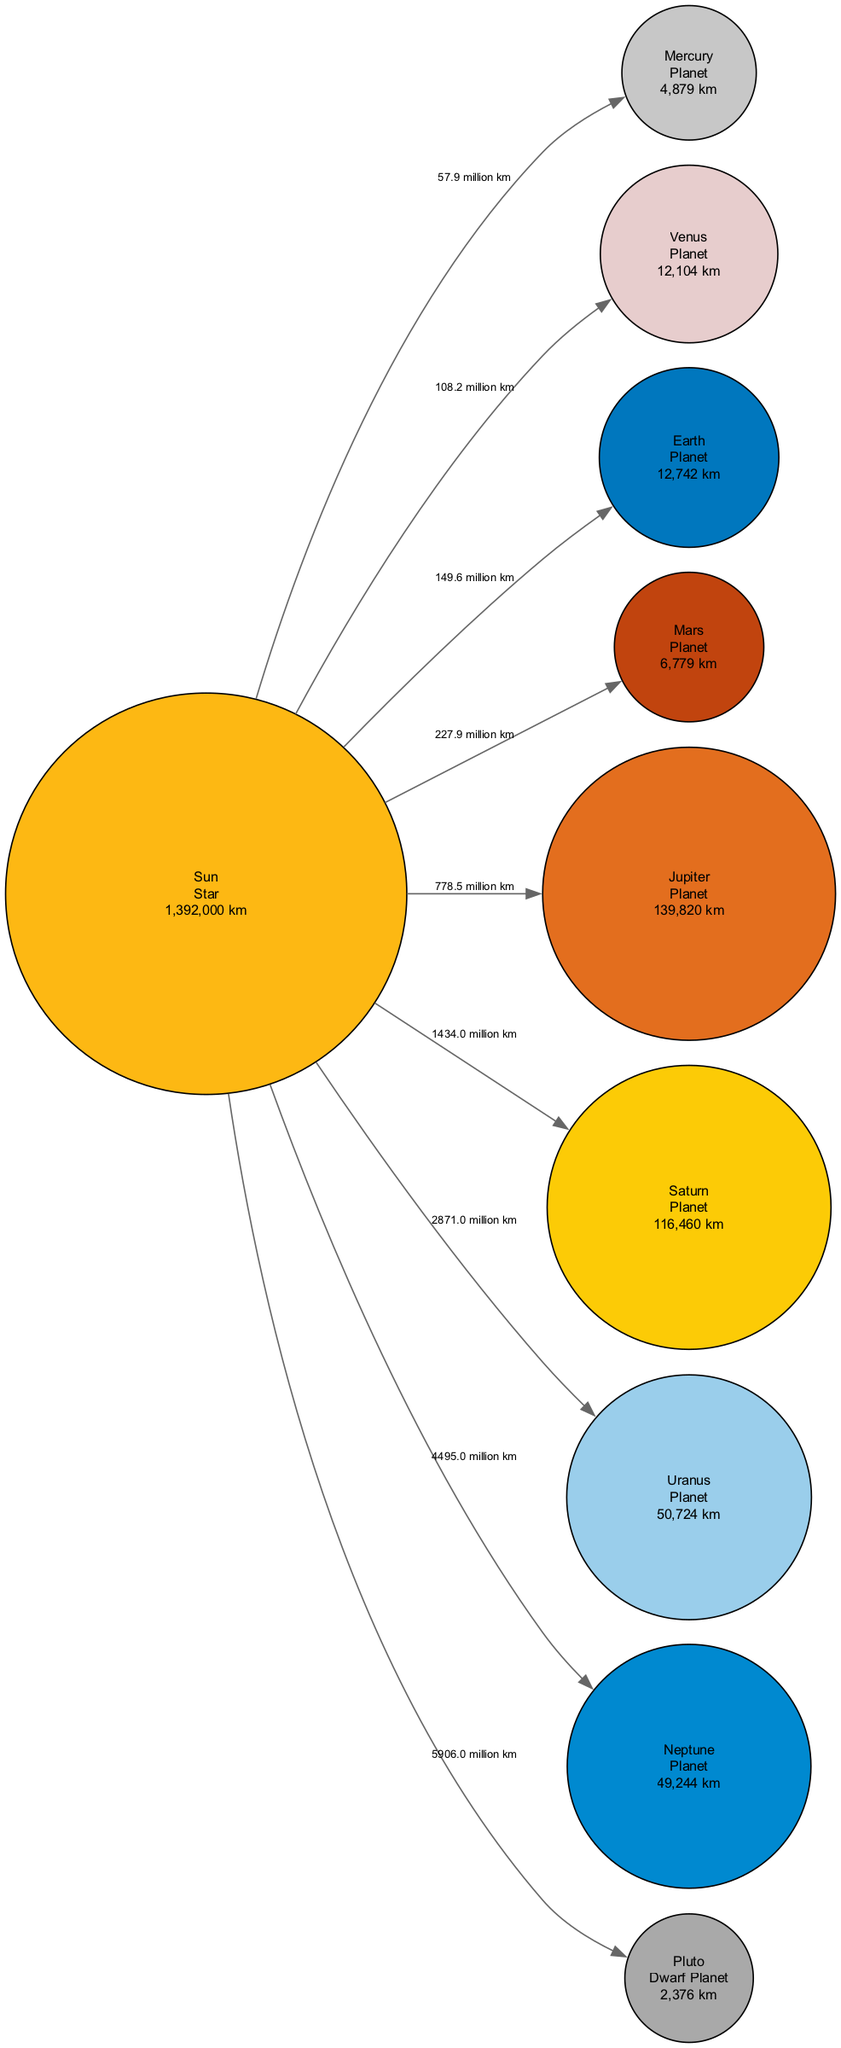What is the diameter of Jupiter? By locating the node for Jupiter in the diagram and checking its description, the diameter is listed directly as 139,820 km.
Answer: 139,820 km Which planet is the farthest from the Sun? The diagram shows connections from the Sun to each planet, and the distance to Neptune is the greatest at 4,495,000,000 km.
Answer: Neptune How many planets are in the Solar System according to the diagram? The diagram contains eight planets, plus one dwarf planet (Pluto), indicating a total of nine celestial bodies (noting that only the planets count as planets).
Answer: 8 What is the distance from the Sun to Saturn? By inspecting the edge connecting the Sun to Saturn, the distance specified in the diagram is 1,434,000,000 km.
Answer: 1,434,000,000 km Which celestial body has a diameter closest to that of Earth? Comparing the diameter values listed for Venus (12,104 km) and Earth (12,742 km), Venus is the closest in size.
Answer: Venus What is the total distance from the Sun to all planets? To find the total distance, we add the distances from the Sun to each planet: ... (step by step calculations for each distance listed) ... This leads to a total distance from the Sun to all planets of about 6,905,700,000 km.
Answer: 6,905,700,000 km Which planet is known for its rings? The diagram explicitly lists Saturn, describing it as "Famous for its ring system."
Answer: Saturn What is the smallest celestial body in the Solar System depicted in the diagram? The diagram shows that Pluto has the smallest diameter at 2,376 km.
Answer: Pluto 